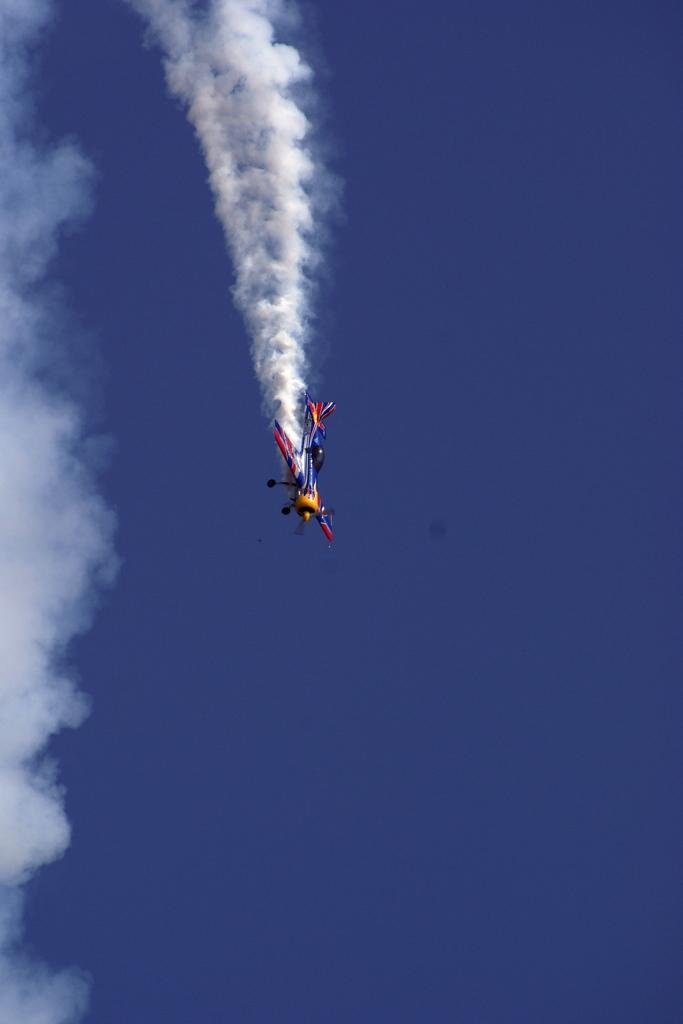What is the main subject of the image? The main subject of the image is an aircraft. What colors can be seen on the aircraft? The aircraft is yellow, blue, and red in color. What is the aircraft doing in the image? The aircraft is flying in the air. What can be seen behind the aircraft? There is smoke behind the aircraft. What is visible in the background of the image? The sky is visible in the background of the image. Where is the hill located in the image? There is no hill present in the image; it features an aircraft flying in the air. What type of bears can be seen interacting with the aircraft in the image? There are no bears present in the image; it only features an aircraft flying in the air. 